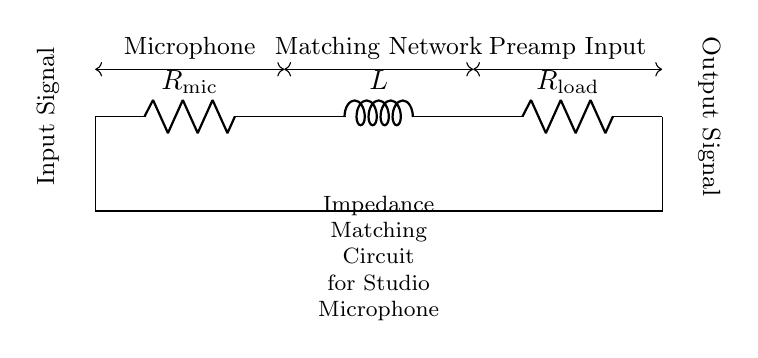What type of components are present in this circuit? The circuit contains two resistors and one inductor, visually identified as R for the microphone and load, and L for the inductor.
Answer: Resistors and an inductor What is the role of the resistor R mic? The resistor R mic serves as the microphone's output impedance, helping to match the impedance with the following circuit stage for optimal power transfer.
Answer: Output impedance matching What is the term used for the circuit's purpose? The purpose of this circuit is to match the impedances between the microphone output and the preamplifier input, ensuring efficient signal transfer without distortion.
Answer: Impedance matching If Rload is increased, what effect does it have on the signal? Increasing Rload leads to higher total impedance, which can reduce the overall current in the circuit, potentially affecting the signal level reaching the preamplifier.
Answer: Reduces signal level How do the resistor and inductor affect the phase of the signal? The combination of the resistor and the inductor creates a complex impedance that alters both the magnitude and phase of the input signal, affecting how the signal is processed.
Answer: Alters phase and magnitude What happens to the circuit's impedance at high frequencies? At high frequencies, the inductor's reactance increases, which results in a higher overall impedance and may lead to a lower current through the circuit, impacting the microphone's performance.
Answer: Higher impedance What can replacing the inductor with a capacitor do? Replacing the inductor with a capacitor would fundamentally change the circuit's behavior, potentially allowing for a different type of impedance matching focused on capacitive reactance instead of inductive.
Answer: Changes impedance characteristics 